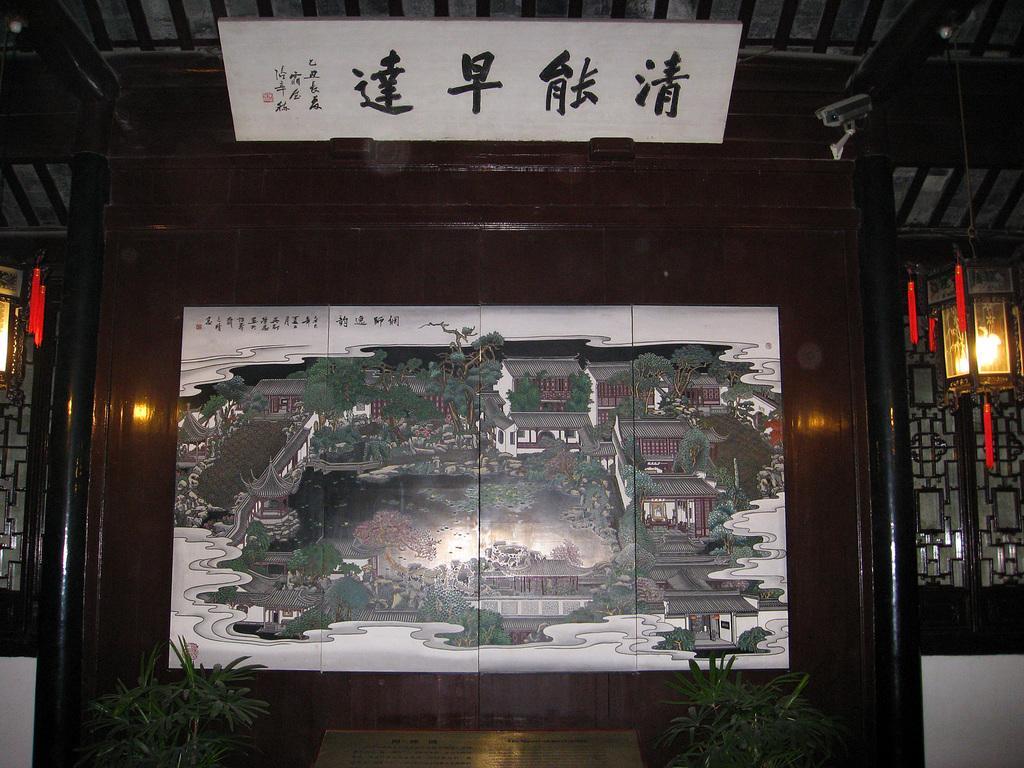Could you give a brief overview of what you see in this image? In this picture there is a painting which is kept on the wooden wall. In that painting I can see building, trees, water, fencing, birds and sky. At the bottom there are two plants which are kept near to the painting. On the right and left side I can see the chandeliers. At the top there is a banner which is kept on this wooden wall. Beside that there is a CCTV camera. 